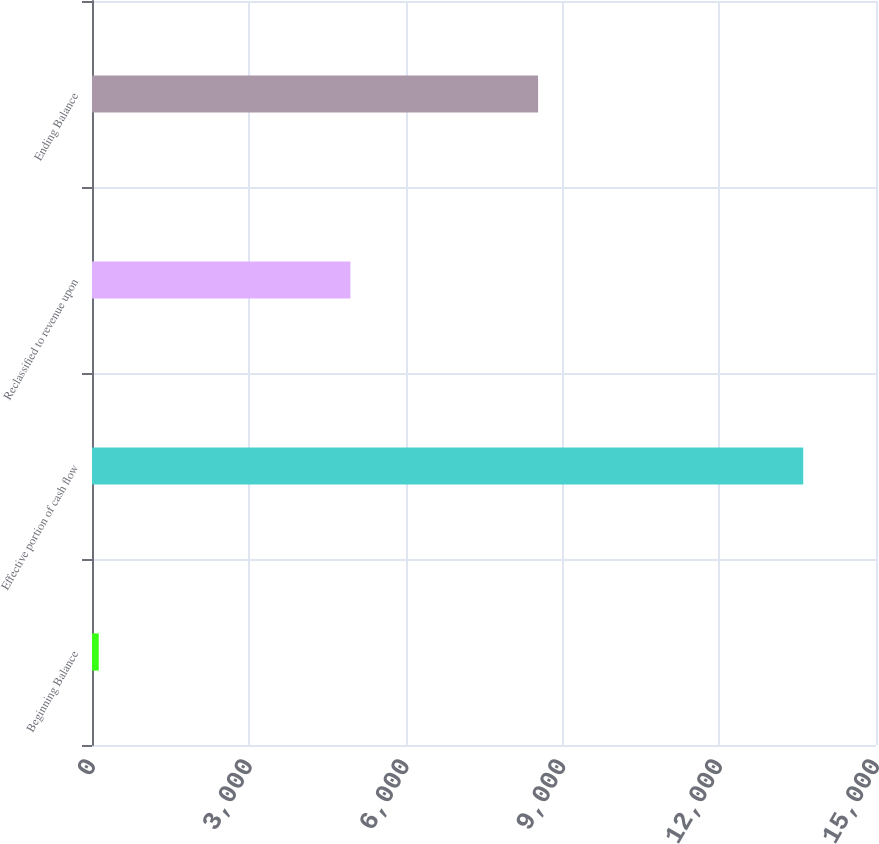Convert chart. <chart><loc_0><loc_0><loc_500><loc_500><bar_chart><fcel>Beginning Balance<fcel>Effective portion of cash flow<fcel>Reclassified to revenue upon<fcel>Ending Balance<nl><fcel>129<fcel>13608<fcel>4944<fcel>8535<nl></chart> 